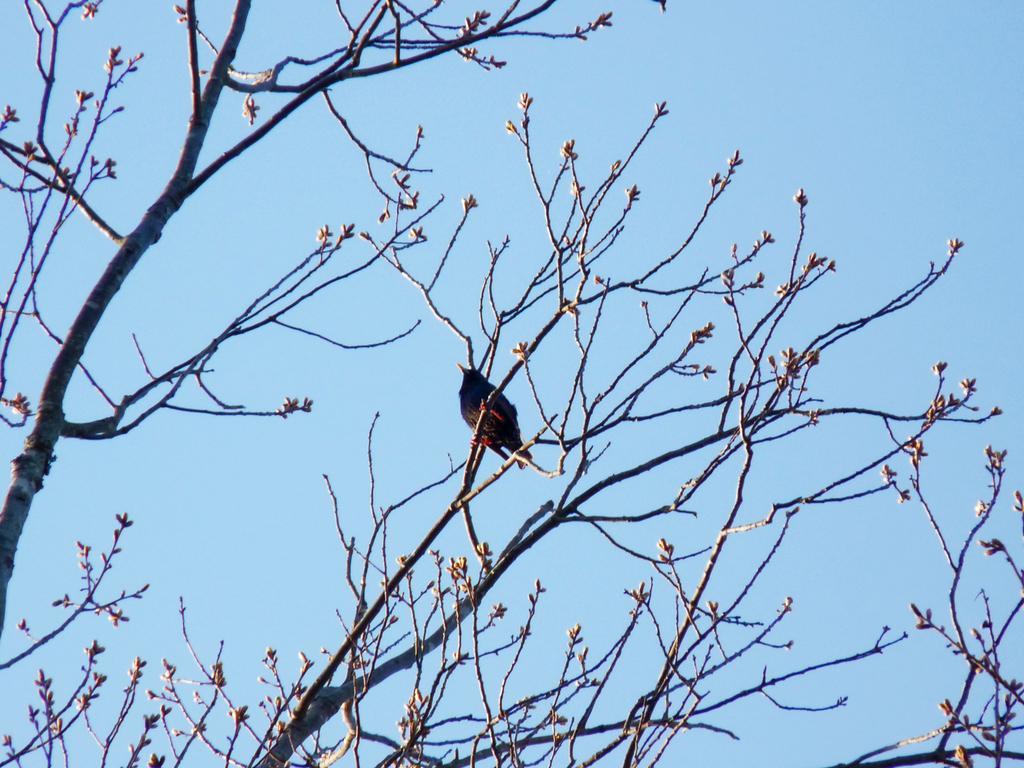Describe this image in one or two sentences. In this image we can see a bird sitting on the small branches of the tree. And we can see the sky. 